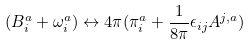Convert formula to latex. <formula><loc_0><loc_0><loc_500><loc_500>( B ^ { a } _ { i } + \omega ^ { a } _ { i } ) \leftrightarrow 4 \pi ( \pi ^ { a } _ { i } + \frac { 1 } { 8 \pi } \epsilon _ { i j } A ^ { j , a } )</formula> 